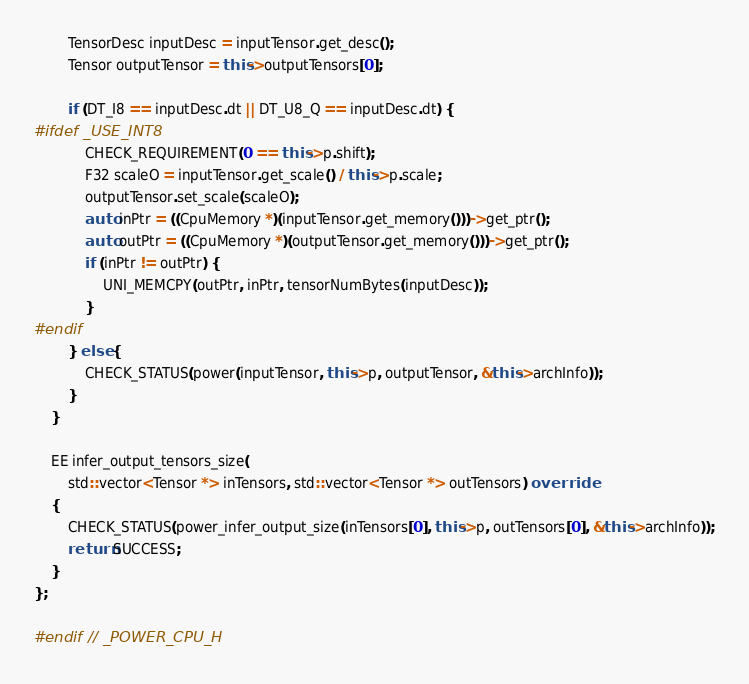<code> <loc_0><loc_0><loc_500><loc_500><_C++_>        TensorDesc inputDesc = inputTensor.get_desc();
        Tensor outputTensor = this->outputTensors[0];

        if (DT_I8 == inputDesc.dt || DT_U8_Q == inputDesc.dt) {
#ifdef _USE_INT8
            CHECK_REQUIREMENT(0 == this->p.shift);
            F32 scaleO = inputTensor.get_scale() / this->p.scale;
            outputTensor.set_scale(scaleO);
            auto inPtr = ((CpuMemory *)(inputTensor.get_memory()))->get_ptr();
            auto outPtr = ((CpuMemory *)(outputTensor.get_memory()))->get_ptr();
            if (inPtr != outPtr) {
                UNI_MEMCPY(outPtr, inPtr, tensorNumBytes(inputDesc));
            }
#endif
        } else {
            CHECK_STATUS(power(inputTensor, this->p, outputTensor, &this->archInfo));
        }
    }

    EE infer_output_tensors_size(
        std::vector<Tensor *> inTensors, std::vector<Tensor *> outTensors) override
    {
        CHECK_STATUS(power_infer_output_size(inTensors[0], this->p, outTensors[0], &this->archInfo));
        return SUCCESS;
    }
};

#endif  // _POWER_CPU_H
</code> 